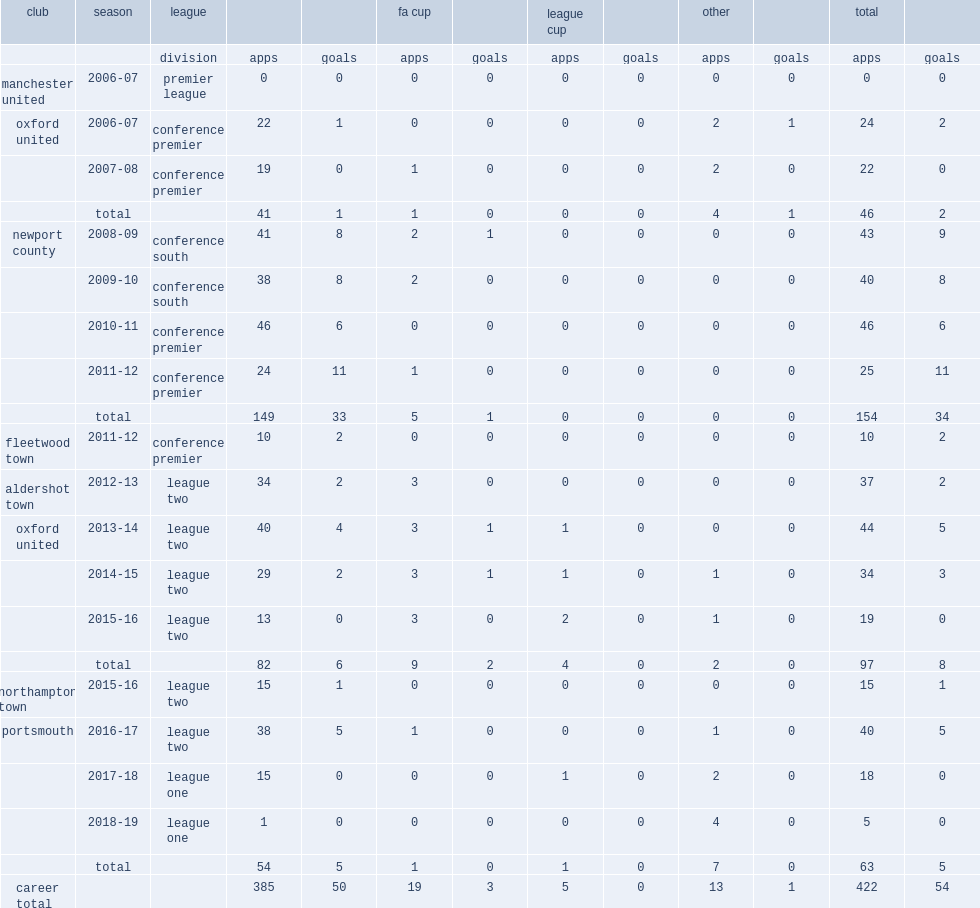Before returning to oxford in 2013, which club did danny rose appear in the 2011-12 conference premier? Fleetwood town. 